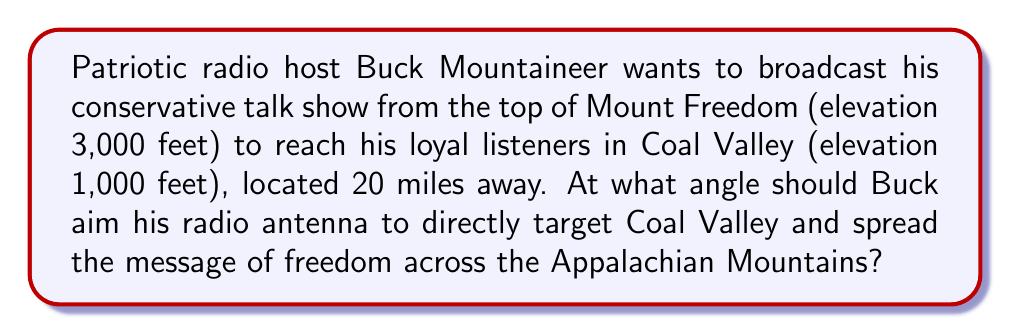Could you help me with this problem? Let's approach this problem step-by-step using trigonometry:

1) First, we need to visualize the scenario:
   [asy]
   import geometry;
   
   size(200);
   
   pair A = (0,0);
   pair B = (20,0);
   pair C = (0,3);
   pair D = (20,1);
   
   draw(A--B--D--C--A);
   draw(C--D,dashed);
   
   label("Mount Freedom", A, SW);
   label("Coal Valley", B, SE);
   label("3000 ft", C, NW);
   label("1000 ft", D, NE);
   label("20 miles", (10,0), S);
   label("$\theta$", (0.5,0.5), NE);
   
   [/asy]

2) We need to find the angle $\theta$ that the radio antenna should be aimed at.

3) We can use the tangent function to calculate this angle. The tangent of an angle is the opposite side divided by the adjacent side.

4) The opposite side is the difference in elevation: 3000 ft - 1000 ft = 2000 ft

5) The adjacent side is the horizontal distance: 20 miles

6) However, we need to convert miles to feet for consistency:
   20 miles = 20 * 5280 = 105,600 ft

7) Now we can set up our tangent equation:

   $$\tan(\theta) = \frac{\text{opposite}}{\text{adjacent}} = \frac{2000}{105600}$$

8) To find $\theta$, we need to use the inverse tangent (arctan) function:

   $$\theta = \arctan(\frac{2000}{105600})$$

9) Using a calculator or computer:

   $$\theta \approx 1.0857 \text{ degrees}$$

This angle will ensure that Buck's conservative message reaches directly to Coal Valley, spreading freedom across the Appalachian Mountains!
Answer: $1.09^\circ$ 